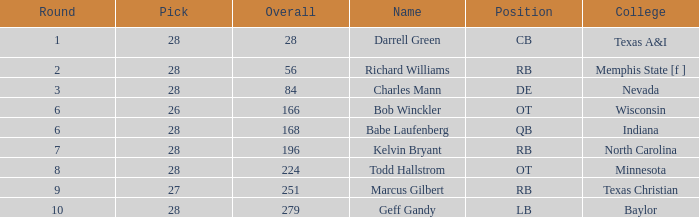What is the typical round of the player from the college of baylor with a draft choice below 28? None. 